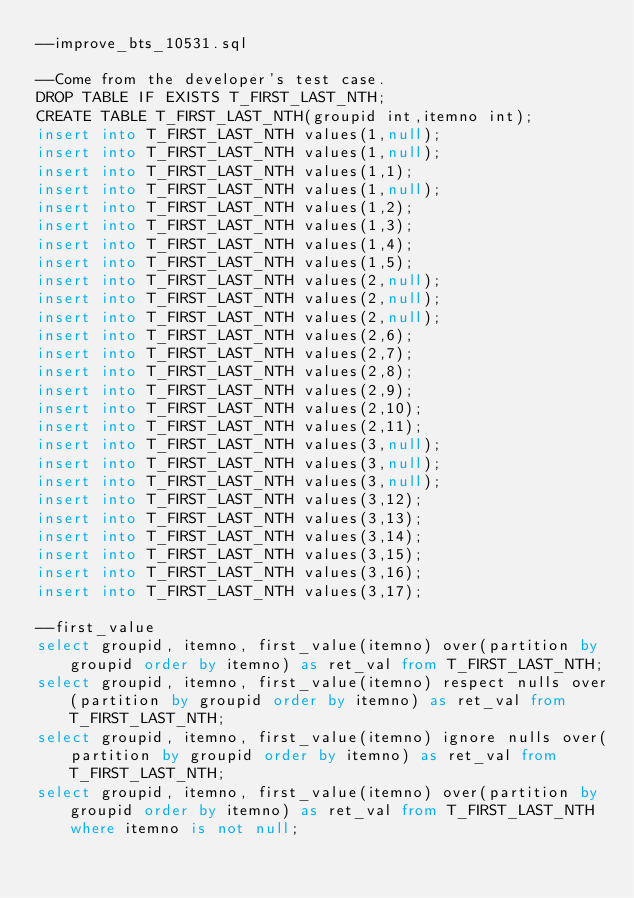Convert code to text. <code><loc_0><loc_0><loc_500><loc_500><_SQL_>--improve_bts_10531.sql

--Come from the developer's test case.
DROP TABLE IF EXISTS T_FIRST_LAST_NTH;
CREATE TABLE T_FIRST_LAST_NTH(groupid int,itemno int);
insert into T_FIRST_LAST_NTH values(1,null);
insert into T_FIRST_LAST_NTH values(1,null);
insert into T_FIRST_LAST_NTH values(1,1);
insert into T_FIRST_LAST_NTH values(1,null);
insert into T_FIRST_LAST_NTH values(1,2);
insert into T_FIRST_LAST_NTH values(1,3);
insert into T_FIRST_LAST_NTH values(1,4);
insert into T_FIRST_LAST_NTH values(1,5);
insert into T_FIRST_LAST_NTH values(2,null);
insert into T_FIRST_LAST_NTH values(2,null);
insert into T_FIRST_LAST_NTH values(2,null);
insert into T_FIRST_LAST_NTH values(2,6);
insert into T_FIRST_LAST_NTH values(2,7);
insert into T_FIRST_LAST_NTH values(2,8);
insert into T_FIRST_LAST_NTH values(2,9);
insert into T_FIRST_LAST_NTH values(2,10);
insert into T_FIRST_LAST_NTH values(2,11);
insert into T_FIRST_LAST_NTH values(3,null);
insert into T_FIRST_LAST_NTH values(3,null);
insert into T_FIRST_LAST_NTH values(3,null);
insert into T_FIRST_LAST_NTH values(3,12);
insert into T_FIRST_LAST_NTH values(3,13);
insert into T_FIRST_LAST_NTH values(3,14);
insert into T_FIRST_LAST_NTH values(3,15);
insert into T_FIRST_LAST_NTH values(3,16);
insert into T_FIRST_LAST_NTH values(3,17);

--first_value
select groupid, itemno, first_value(itemno) over(partition by groupid order by itemno) as ret_val from T_FIRST_LAST_NTH;
select groupid, itemno, first_value(itemno) respect nulls over(partition by groupid order by itemno) as ret_val from T_FIRST_LAST_NTH;
select groupid, itemno, first_value(itemno) ignore nulls over(partition by groupid order by itemno) as ret_val from T_FIRST_LAST_NTH;
select groupid, itemno, first_value(itemno) over(partition by groupid order by itemno) as ret_val from T_FIRST_LAST_NTH where itemno is not null;</code> 